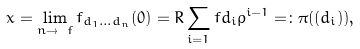Convert formula to latex. <formula><loc_0><loc_0><loc_500><loc_500>x = \lim _ { n \to \ f } f _ { d _ { 1 } \dots d _ { n } } ( 0 ) = R \sum _ { i = 1 } ^ { \ } f d _ { i } \rho ^ { i - 1 } = \colon \pi ( ( d _ { i } ) ) ,</formula> 